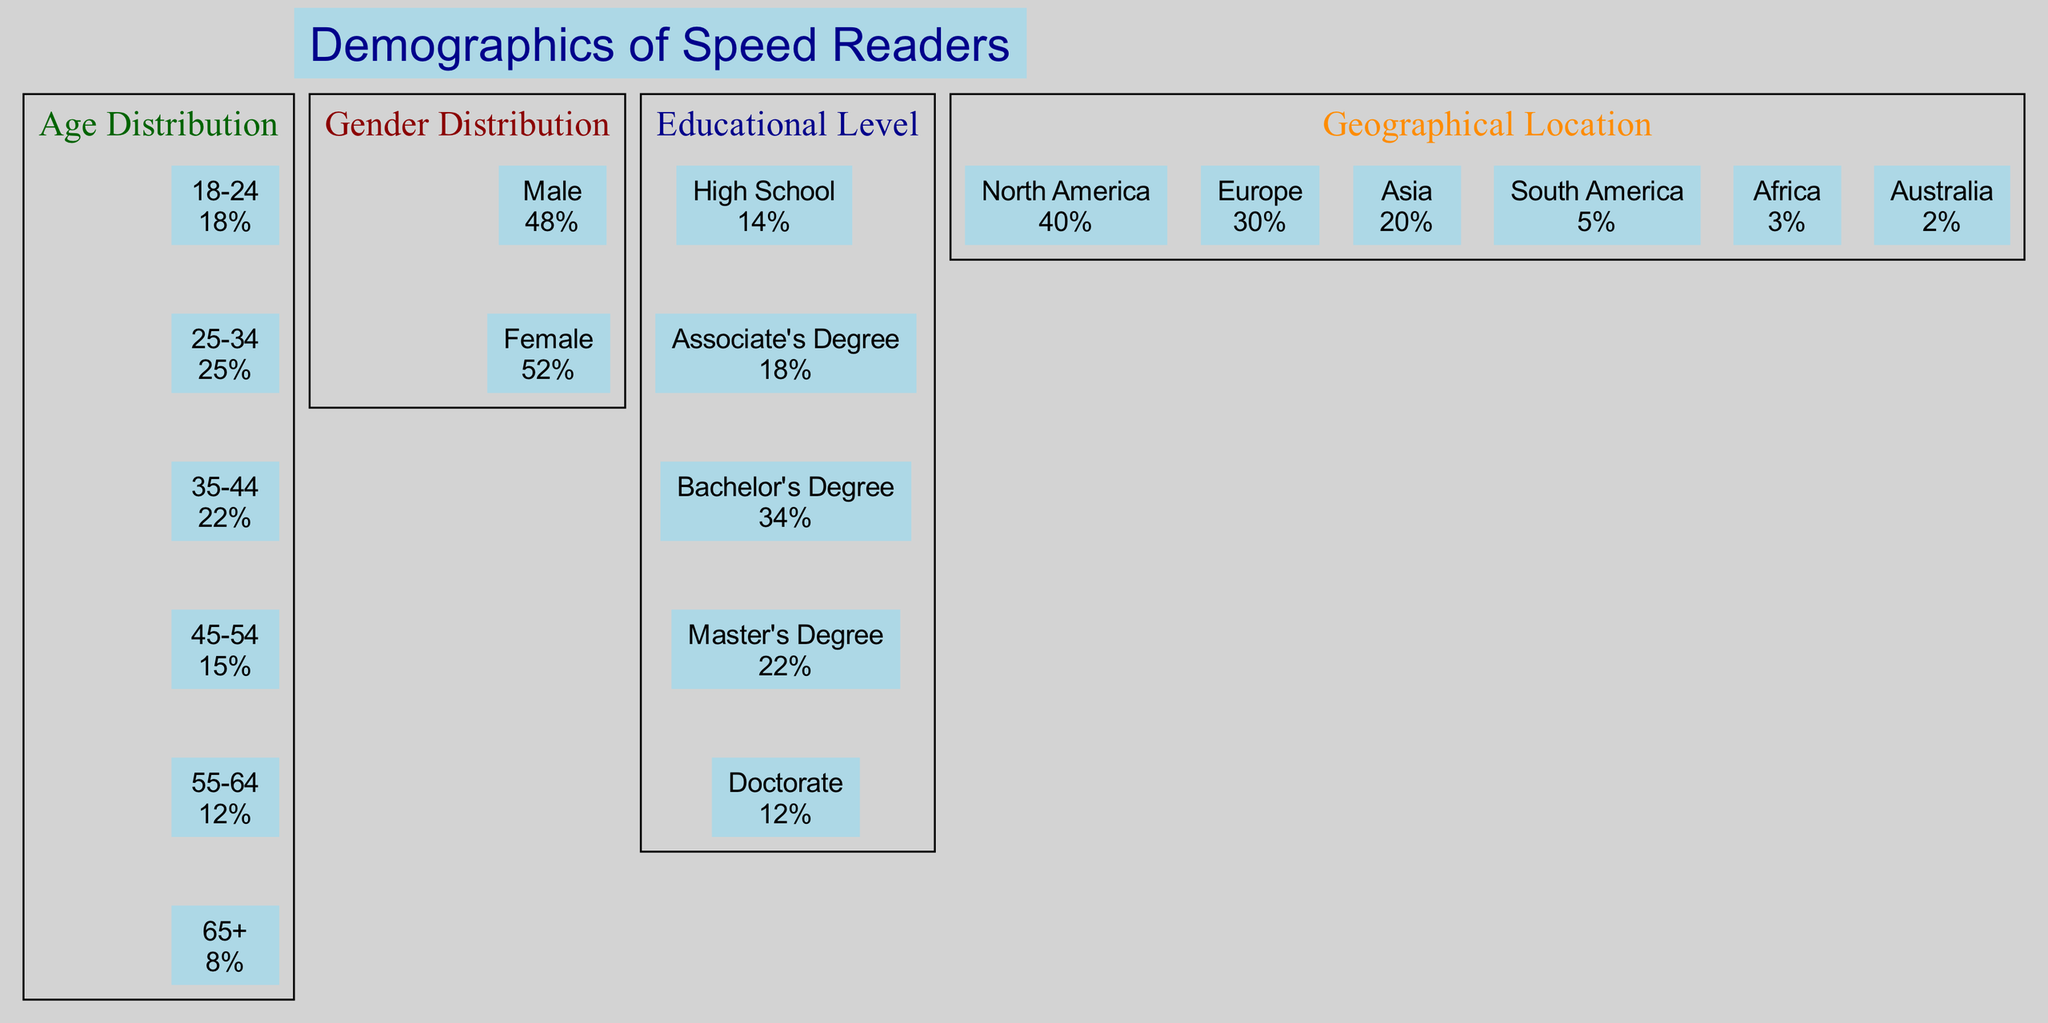What is the age group with the highest percentage of speed readers? By looking at the bar graph for Age Distribution, the group with the highest value is 25-34, which has a percentage of 25%.
Answer: 25-34 What percentage of speed readers are female? In the Gender Distribution bar graph, the value for Female is represented, which shows that 52% of speed readers are female.
Answer: 52% How many age groups are represented in the Age Distribution graph? The Age Distribution graph includes six different age groups: 18-24, 25-34, 35-44, 45-54, 55-64, and 65+. Therefore, the count of age groups is 6.
Answer: 6 What is the percentage of speed readers with a Master's Degree? From the Educational Level bar graph, the entry for Master's Degree shows a percentage of 22%.
Answer: 22% Which geographical region has the lowest percentage of speed readers? In the Geographical Location section, the region with the lowest value is Australia, with only 2% of speed readers from that region.
Answer: Australia What percentage of speed readers have a Bachelor's Degree or higher? To find this, we must sum the percentages of Bachelor's Degree (34%), Master's Degree (22%), and Doctorate (12%). Combining these gives 34 + 22 + 12 = 68%.
Answer: 68% What is the percentage difference between male and female speed readers? The percentage of Male speed readers is 48% and Female speed readers is 52%. The difference is calculated as 52 - 48 = 4%.
Answer: 4% What percentage of speed readers come from North America? In the Geographical Location section, the value for North America is listed as 40%.
Answer: 40% What age group represents 18% of speed readers? In the Age Distribution graph, the age group that corresponds to 18% is 25-34.
Answer: 25-34 